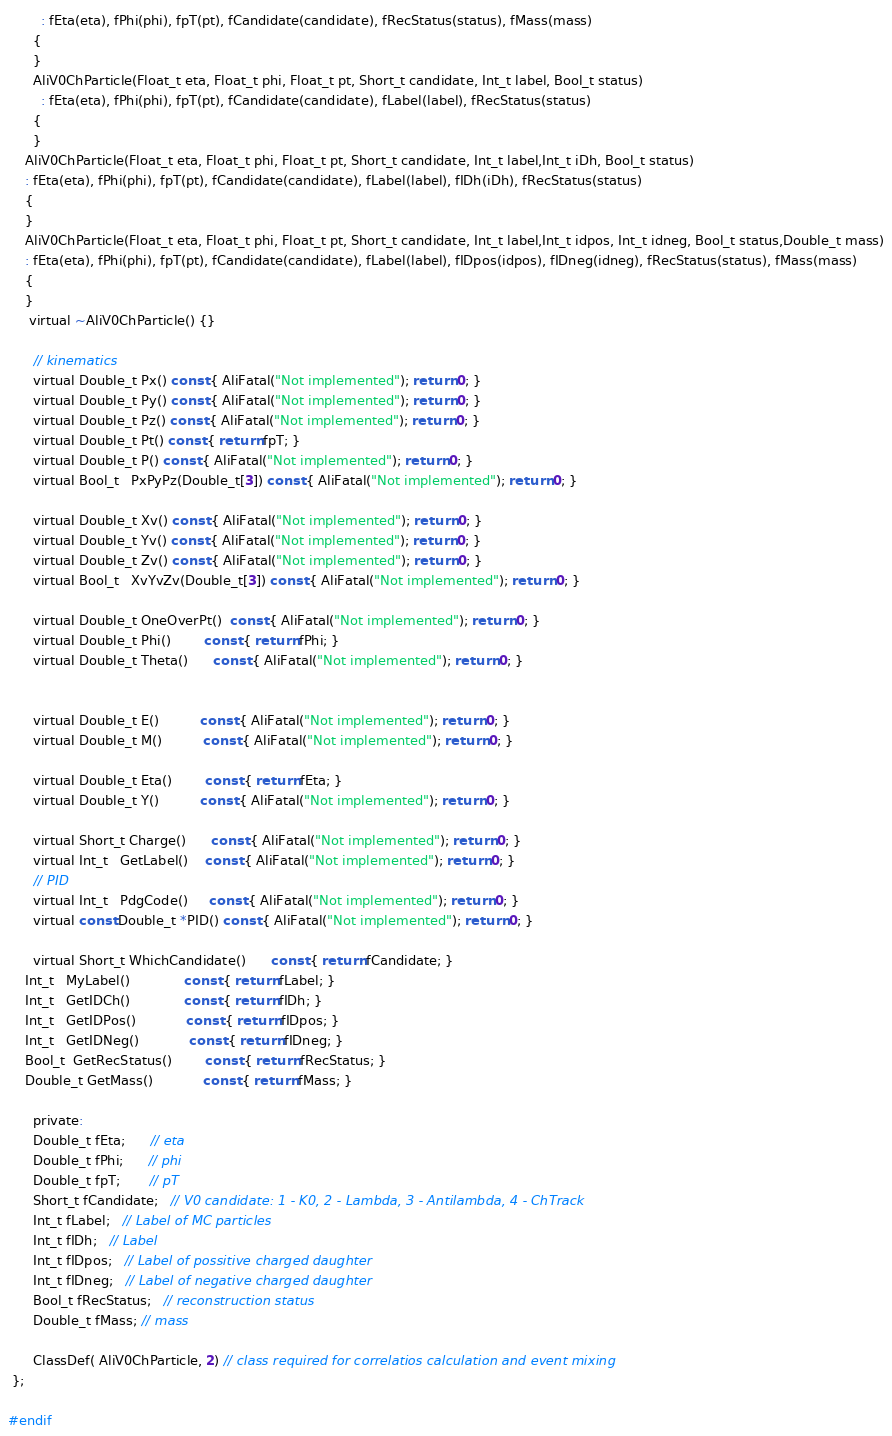<code> <loc_0><loc_0><loc_500><loc_500><_C_>        : fEta(eta), fPhi(phi), fpT(pt), fCandidate(candidate), fRecStatus(status), fMass(mass)
      {
      }
      AliV0ChParticle(Float_t eta, Float_t phi, Float_t pt, Short_t candidate, Int_t label, Bool_t status)
        : fEta(eta), fPhi(phi), fpT(pt), fCandidate(candidate), fLabel(label), fRecStatus(status)
      {
      }
    AliV0ChParticle(Float_t eta, Float_t phi, Float_t pt, Short_t candidate, Int_t label,Int_t iDh, Bool_t status)
    : fEta(eta), fPhi(phi), fpT(pt), fCandidate(candidate), fLabel(label), fIDh(iDh), fRecStatus(status)
    {
    }
    AliV0ChParticle(Float_t eta, Float_t phi, Float_t pt, Short_t candidate, Int_t label,Int_t idpos, Int_t idneg, Bool_t status,Double_t mass)
    : fEta(eta), fPhi(phi), fpT(pt), fCandidate(candidate), fLabel(label), fIDpos(idpos), fIDneg(idneg), fRecStatus(status), fMass(mass)
    {
    }
     virtual ~AliV0ChParticle() {}
  
      // kinematics
      virtual Double_t Px() const { AliFatal("Not implemented"); return 0; }
      virtual Double_t Py() const { AliFatal("Not implemented"); return 0; }
      virtual Double_t Pz() const { AliFatal("Not implemented"); return 0; }
      virtual Double_t Pt() const { return fpT; }
      virtual Double_t P() const { AliFatal("Not implemented"); return 0; }
      virtual Bool_t   PxPyPz(Double_t[3]) const { AliFatal("Not implemented"); return 0; }
  
      virtual Double_t Xv() const { AliFatal("Not implemented"); return 0; }
      virtual Double_t Yv() const { AliFatal("Not implemented"); return 0; }
      virtual Double_t Zv() const { AliFatal("Not implemented"); return 0; }
      virtual Bool_t   XvYvZv(Double_t[3]) const { AliFatal("Not implemented"); return 0; }
  
      virtual Double_t OneOverPt()  const { AliFatal("Not implemented"); return 0; }
      virtual Double_t Phi()        const { return fPhi; }
      virtual Double_t Theta()      const { AliFatal("Not implemented"); return 0; }
  
  
      virtual Double_t E()          const { AliFatal("Not implemented"); return 0; }
      virtual Double_t M()          const { AliFatal("Not implemented"); return 0; }
  
      virtual Double_t Eta()        const { return fEta; }
      virtual Double_t Y()          const { AliFatal("Not implemented"); return 0; }
  
      virtual Short_t Charge()      const { AliFatal("Not implemented"); return 0; }
      virtual Int_t   GetLabel()    const { AliFatal("Not implemented"); return 0; }
      // PID
      virtual Int_t   PdgCode()     const { AliFatal("Not implemented"); return 0; }
      virtual const Double_t *PID() const { AliFatal("Not implemented"); return 0; }
  
      virtual Short_t WhichCandidate()      const { return fCandidate; }
    Int_t   MyLabel()             const { return fLabel; }
    Int_t   GetIDCh()             const { return fIDh; }
    Int_t   GetIDPos()            const { return fIDpos; }
    Int_t   GetIDNeg()            const { return fIDneg; }
    Bool_t  GetRecStatus()        const { return fRecStatus; }
    Double_t GetMass()            const { return fMass; }
  
      private:
      Double_t fEta;      // eta
      Double_t fPhi;      // phi
      Double_t fpT;       // pT
      Short_t fCandidate;   // V0 candidate: 1 - K0, 2 - Lambda, 3 - Antilambda, 4 - ChTrack
      Int_t fLabel;   // Label of MC particles
      Int_t fIDh;   // Label
      Int_t fIDpos;   // Label of possitive charged daughter
      Int_t fIDneg;   // Label of negative charged daughter
      Bool_t fRecStatus;   // reconstruction status
      Double_t fMass; // mass
  
      ClassDef( AliV0ChParticle, 2) // class required for correlatios calculation and event mixing
 };

#endif
</code> 